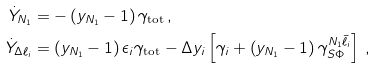<formula> <loc_0><loc_0><loc_500><loc_500>\dot { Y } _ { N _ { 1 } } & = - \left ( y _ { N _ { 1 } } - 1 \right ) \gamma _ { \text {tot} } \, , \\ \dot { Y } _ { \Delta \ell _ { i } } & = \left ( y _ { N _ { 1 } } - 1 \right ) \epsilon _ { i } \gamma _ { \text {tot} } - \Delta y _ { i } \left [ \gamma _ { i } + \left ( y _ { N _ { 1 } } - 1 \right ) \gamma ^ { N _ { 1 } \bar { \ell } _ { i } } _ { S \Phi } \right ] \, ,</formula> 